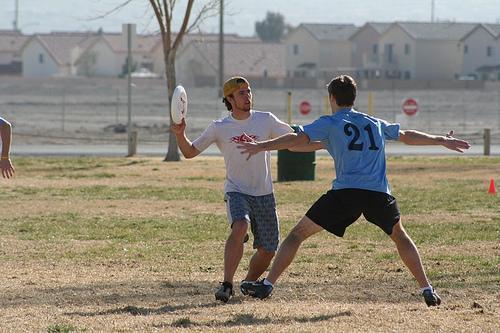How many white shirts are there?
Give a very brief answer. 1. How many people are in the picture?
Give a very brief answer. 2. 